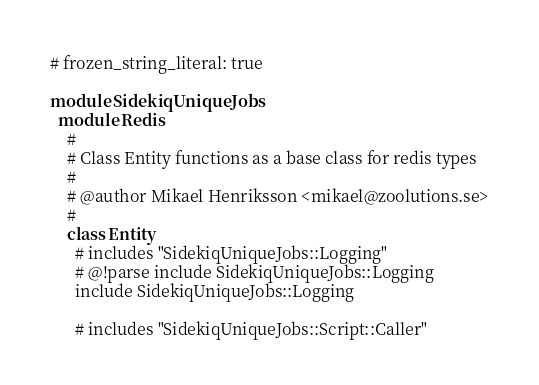<code> <loc_0><loc_0><loc_500><loc_500><_Ruby_># frozen_string_literal: true

module SidekiqUniqueJobs
  module Redis
    #
    # Class Entity functions as a base class for redis types
    #
    # @author Mikael Henriksson <mikael@zoolutions.se>
    #
    class Entity
      # includes "SidekiqUniqueJobs::Logging"
      # @!parse include SidekiqUniqueJobs::Logging
      include SidekiqUniqueJobs::Logging

      # includes "SidekiqUniqueJobs::Script::Caller"</code> 